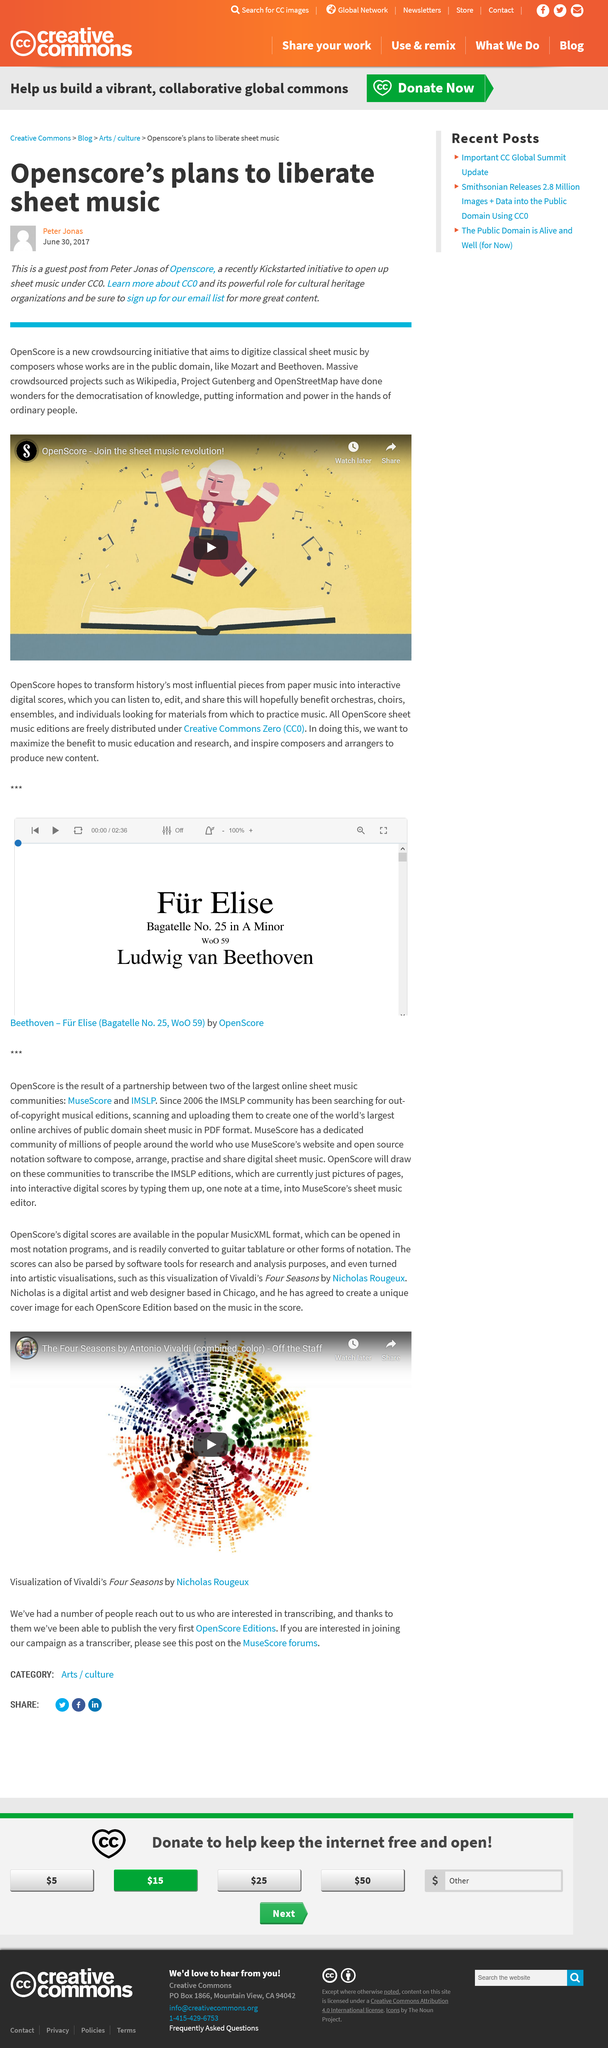Identify some key points in this picture. OpenScore used Kickstarter, a popular crowdfunding platform, for its funding efforts. OpenScore aims to digitize classical sheet music by composers whose works are in the public domain, in order to make these musical treasures more widely accessible and easily accessible to musicians, researchers, and music lovers. Openscore used crowdsourcing to fund itself, and it is known that it did so. 